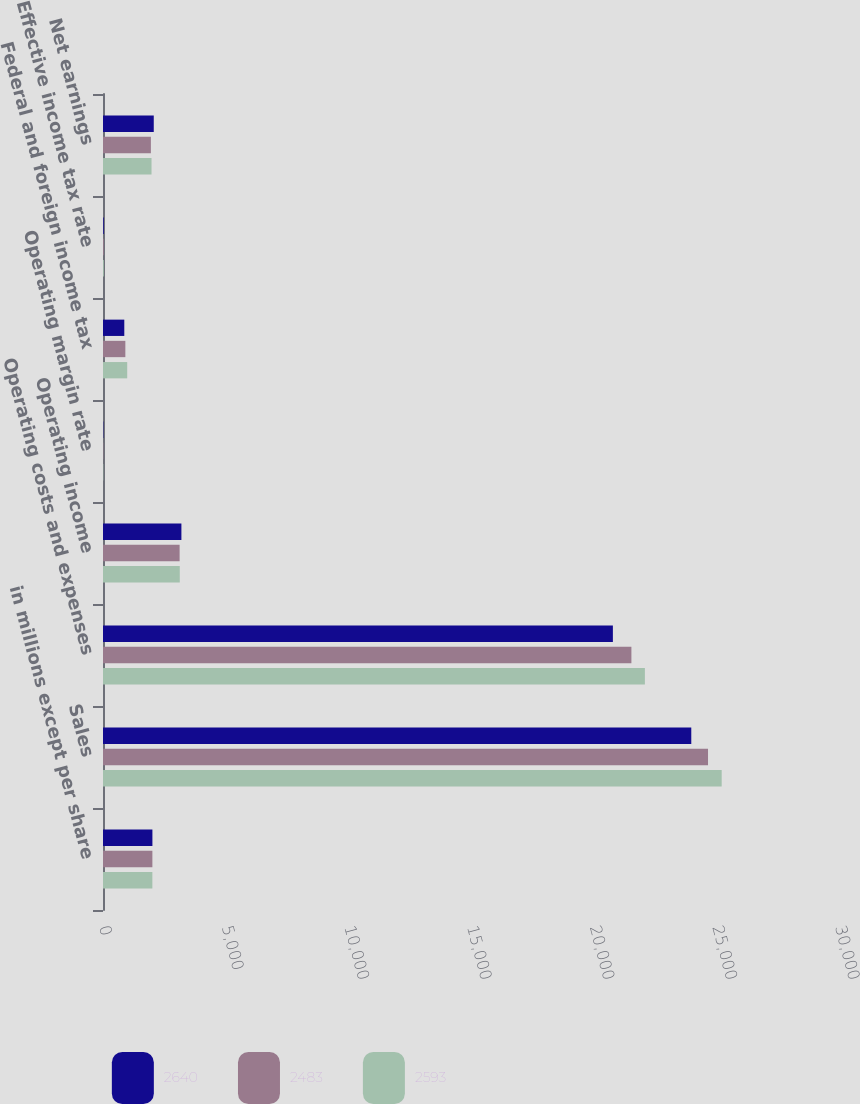<chart> <loc_0><loc_0><loc_500><loc_500><stacked_bar_chart><ecel><fcel>in millions except per share<fcel>Sales<fcel>Operating costs and expenses<fcel>Operating income<fcel>Operating margin rate<fcel>Federal and foreign income tax<fcel>Effective income tax rate<fcel>Net earnings<nl><fcel>2640<fcel>2014<fcel>23979<fcel>20783<fcel>3196<fcel>13.3<fcel>868<fcel>29.6<fcel>2069<nl><fcel>2483<fcel>2013<fcel>24661<fcel>21538<fcel>3123<fcel>12.7<fcel>911<fcel>31.8<fcel>1952<nl><fcel>2593<fcel>2012<fcel>25218<fcel>22088<fcel>3130<fcel>12.4<fcel>987<fcel>33.3<fcel>1978<nl></chart> 